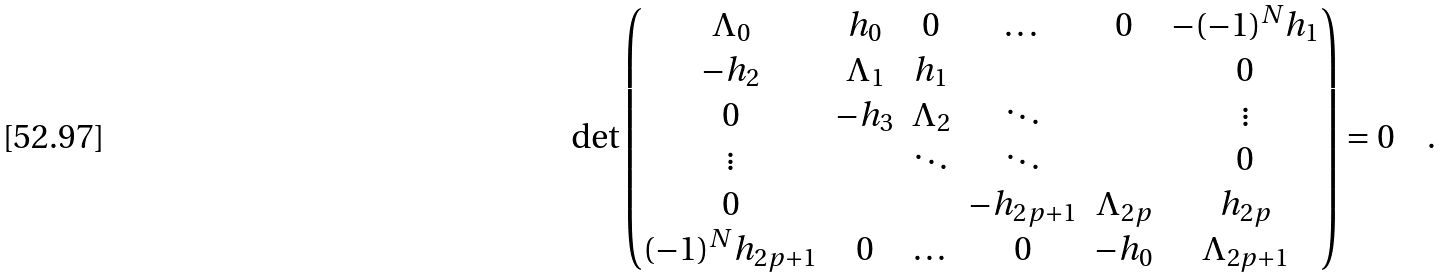Convert formula to latex. <formula><loc_0><loc_0><loc_500><loc_500>\det \begin{pmatrix} \Lambda _ { 0 } & h _ { 0 } & 0 & \dots & 0 & - ( - 1 ) ^ { N } h _ { 1 } \\ - h _ { 2 } & \Lambda _ { 1 } & h _ { 1 } & & & 0 \\ 0 & - h _ { 3 } & \Lambda _ { 2 } & \ddots & & \vdots \\ \vdots & & \ddots & \ddots & & 0 \\ 0 & & & - h _ { 2 p + 1 } & \Lambda _ { 2 p } & h _ { 2 p } \\ ( - 1 ) ^ { N } h _ { 2 p + 1 } & 0 & \dots & 0 & - h _ { 0 } & \Lambda _ { 2 p + 1 } \\ \end{pmatrix} = 0 \quad .</formula> 